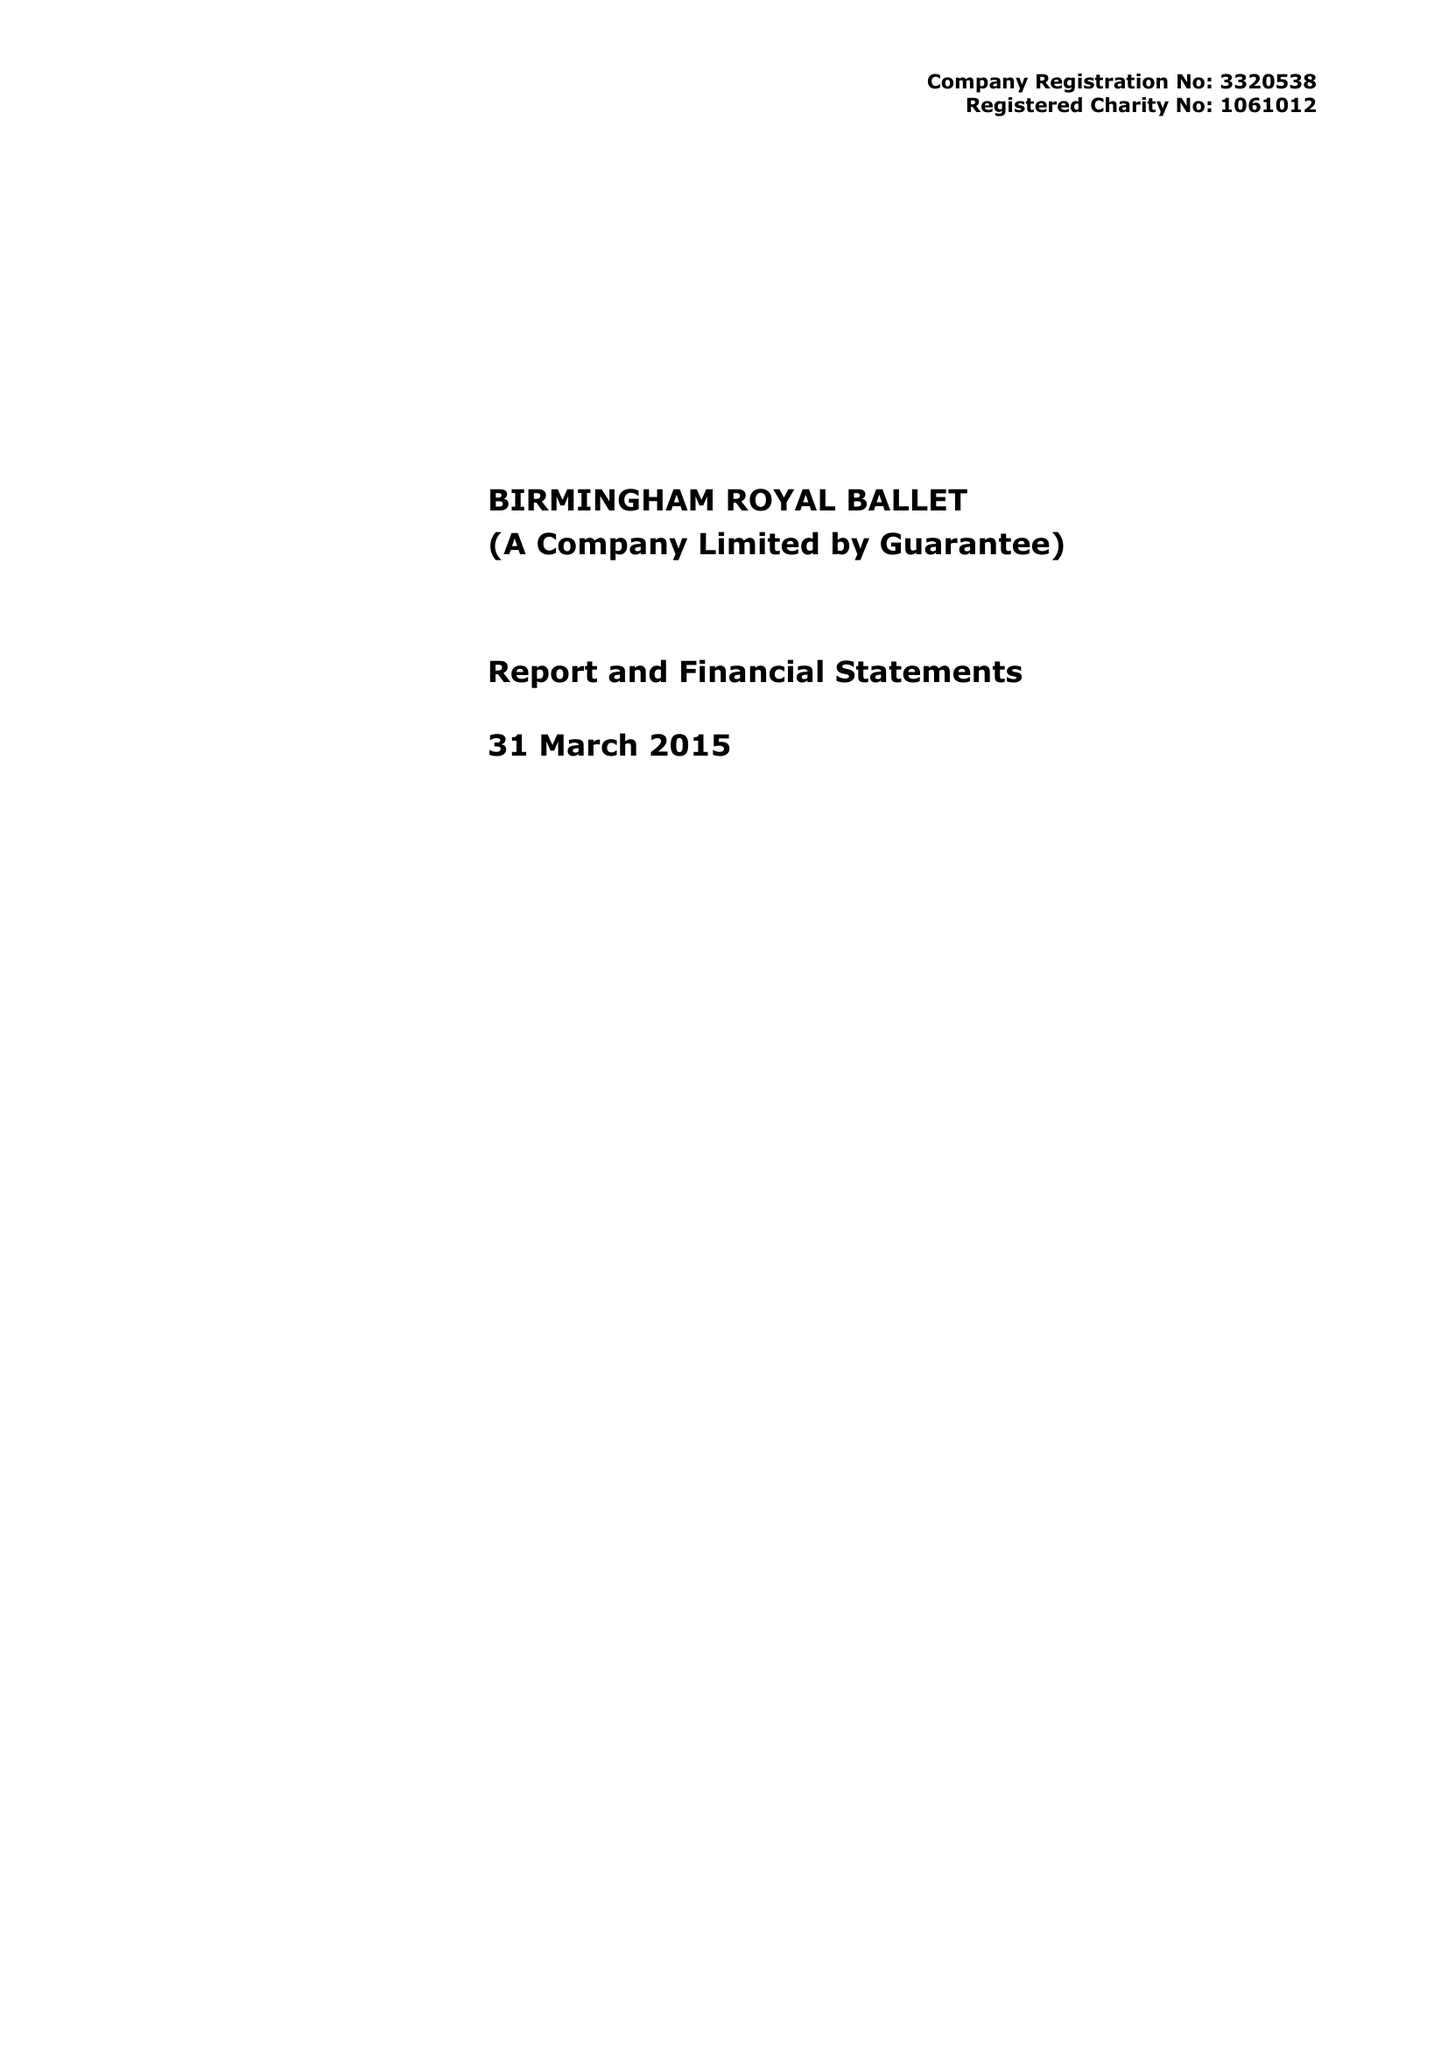What is the value for the income_annually_in_british_pounds?
Answer the question using a single word or phrase. 15429632.00 